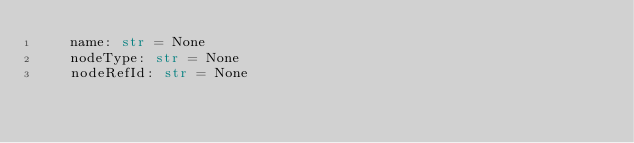Convert code to text. <code><loc_0><loc_0><loc_500><loc_500><_Python_>    name: str = None
    nodeType: str = None
    nodeRefId: str = None
</code> 